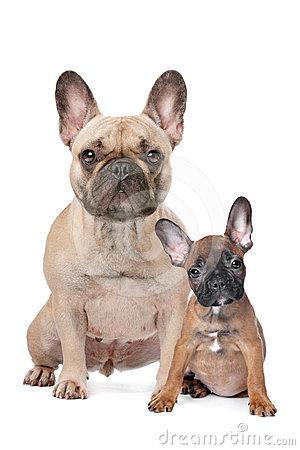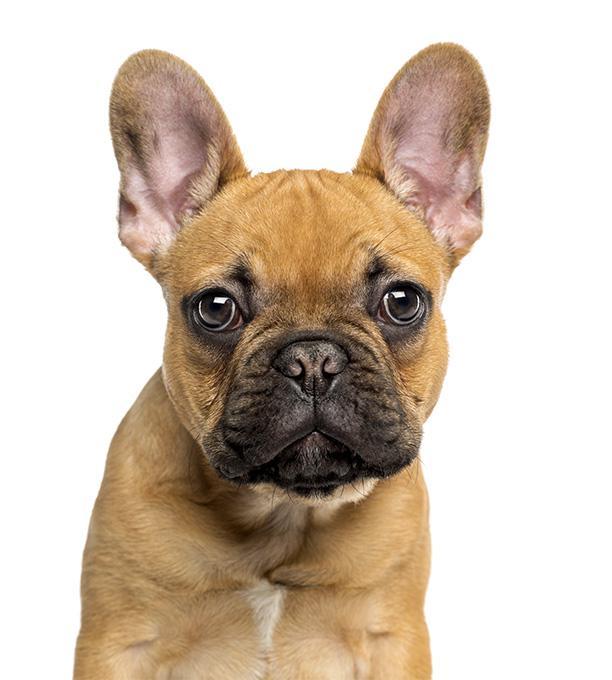The first image is the image on the left, the second image is the image on the right. Analyze the images presented: Is the assertion "the pupply on the left image has its head laying flat on a surface" valid? Answer yes or no. No. 